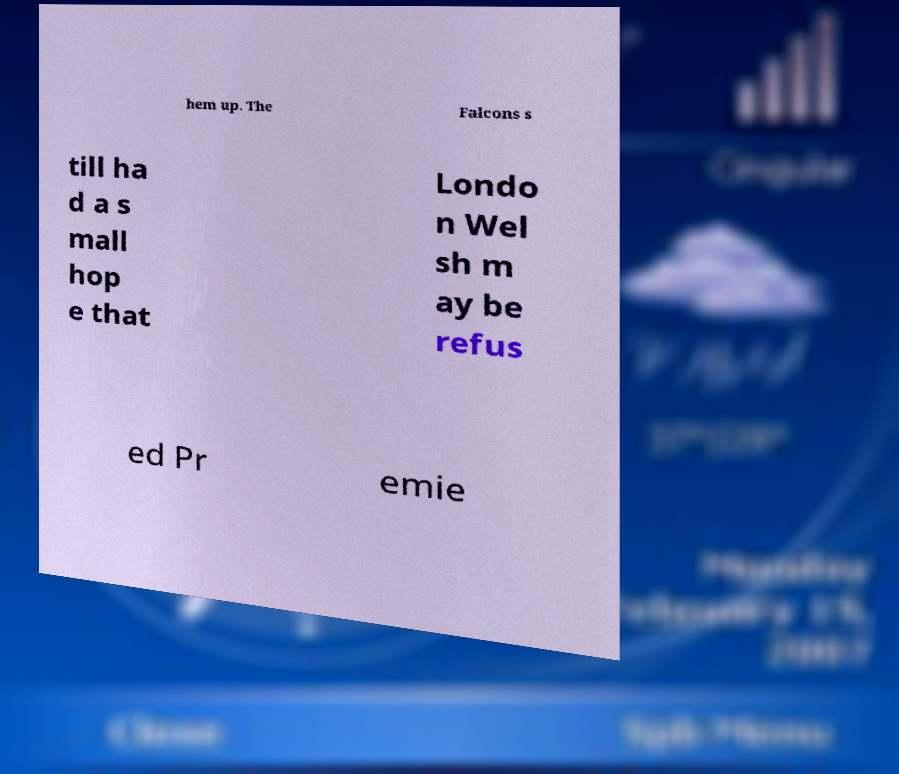Please identify and transcribe the text found in this image. hem up. The Falcons s till ha d a s mall hop e that Londo n Wel sh m ay be refus ed Pr emie 